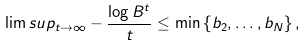<formula> <loc_0><loc_0><loc_500><loc_500>\lim s u p _ { t \to \infty } - \frac { \log B ^ { t } } { t } \leq \min \left \{ b _ { 2 } , \dots , b _ { N } \right \} ,</formula> 